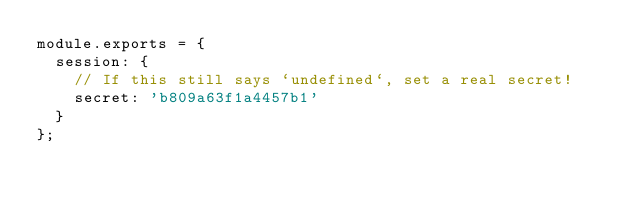Convert code to text. <code><loc_0><loc_0><loc_500><loc_500><_JavaScript_>module.exports = {
  session: {
    // If this still says `undefined`, set a real secret!
    secret: 'b809a63f1a4457b1'
  }
};
</code> 